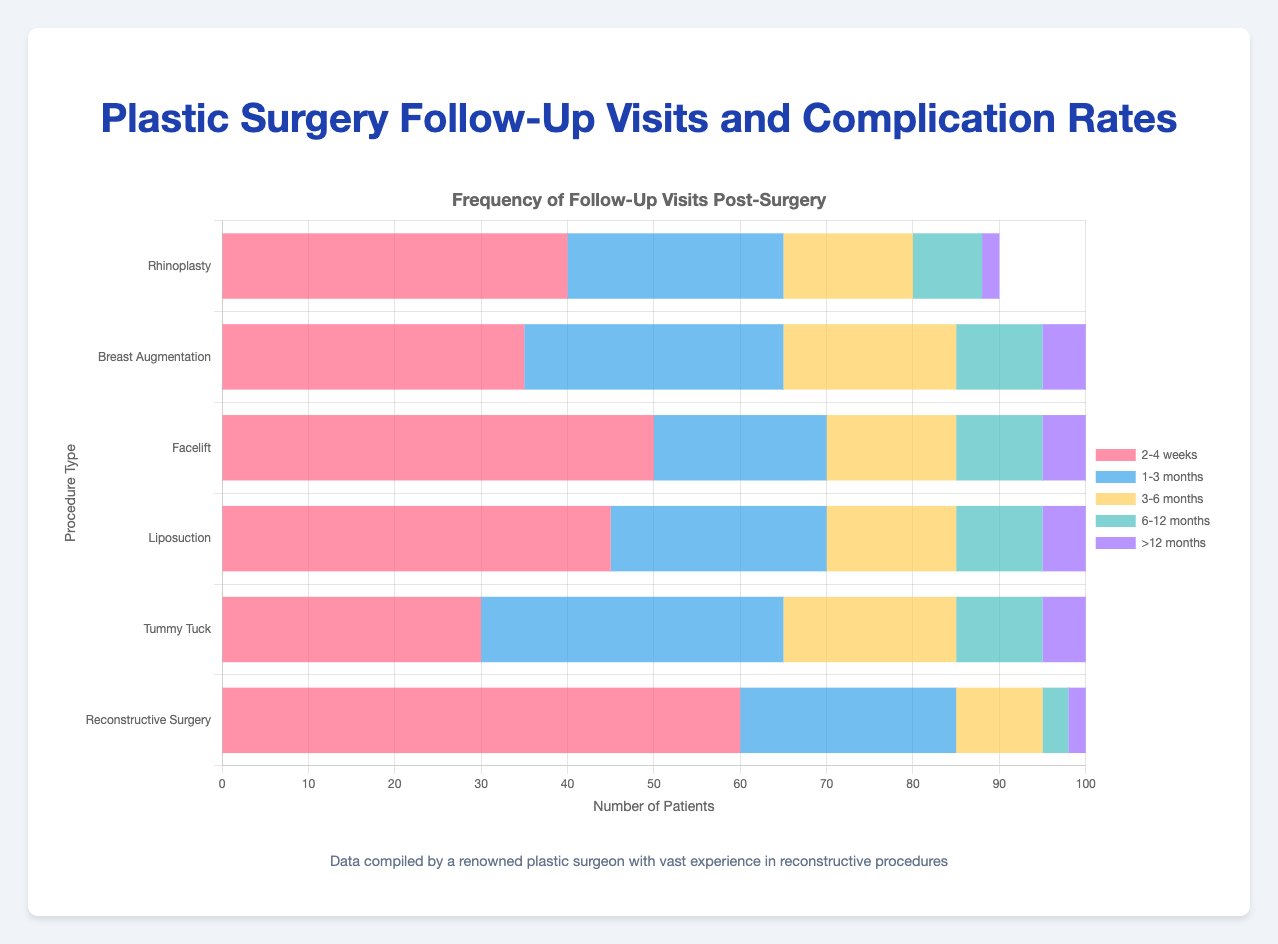Which procedure type has the highest percentage of patients with no complications? From the tooltip information, we can see the breakdown of complication rates for each procedure type. Rhinoplasty leads with 90%.
Answer: Rhinoplasty What is the total number of follow-up visits for Facelift within 3-6 months? Facelift patients had 15 follow-up visits within 3-6 months as indicated by the yellow bar on the chart.
Answer: 15 Which procedure type exhibits the highest number of follow-up visits in the 2-4 weeks category? By comparing the length of the red bars for the '2-4 weeks' category across all procedures, Reconstructive Surgery has the longest bar corresponding to 60 visits.
Answer: Reconstructive Surgery Which procedure has more follow-up visits between 6-12 months compared to Liposuction? First, look at the green bars for the '6-12 months' category. Both Breast Augmentation and Reconstructive Surgery have less than Liposuction's 10 visits.
Answer: None What is the overall complication rate for Breast Augmentation patients? Combining the percentages from the tooltip for Breast Augmentation: 85% (no complications) + 12% (minor) + 3% (major) results in a sum of 100%.
Answer: 100% For which procedure type do the majority of follow-up visits occur within the first 2-4 weeks? By summing up the total visits per follow-up timeframe, Reconstructive Surgery stands out with 60 visits in the 2-4 weeks category.
Answer: Reconstructive Surgery How many more patients experienced no complications in Liposuction compared to Tummy Tuck? Liposuction had 92% while Tummy Tuck had 80%. The difference is 92 - 80 = 12%.
Answer: 12% Which procedure type has the most evenly distributed follow-up visits across all timelines? Upon analyzing the lengths of the bars for each follow-up timeframe per procedure, Breast Augmentation has a relatively balanced distribution, ranging significantly in count but not skewed towards any specific duration.
Answer: Breast Augmentation How many patients required follow-up visits more than 12 months after a Tummy Tuck? From the chart, the number of follow-up visits for Tummy Tuck in the '>12 months' category is indicated by the purple bar which is 5.
Answer: 5 What is the percentage of major complications in Reconstructive Surgery? Detailing the tooltip information for Reconstructive Surgery indicates that 7% of patients experience major complications.
Answer: 7% 